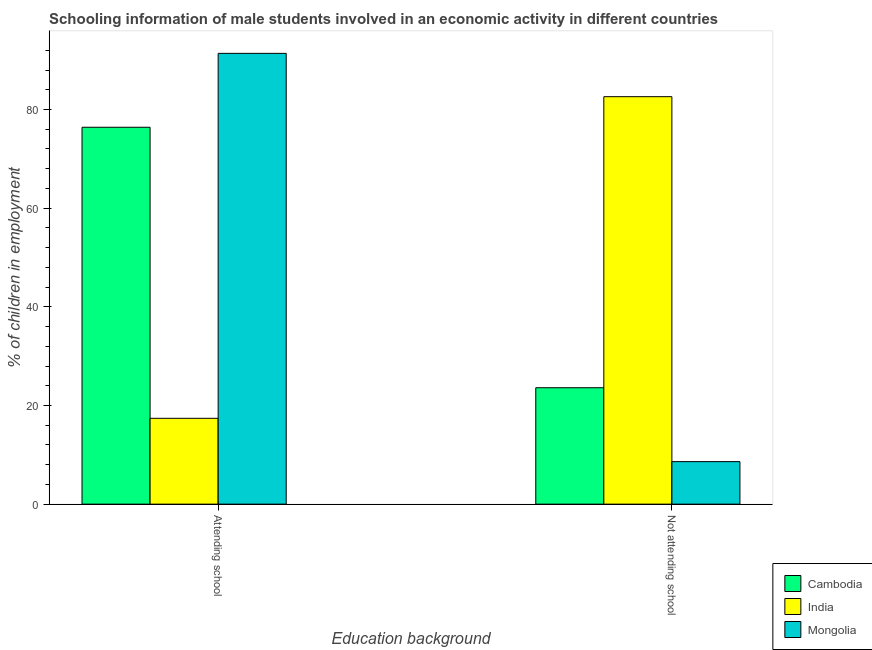Are the number of bars per tick equal to the number of legend labels?
Give a very brief answer. Yes. Are the number of bars on each tick of the X-axis equal?
Keep it short and to the point. Yes. How many bars are there on the 1st tick from the left?
Offer a very short reply. 3. How many bars are there on the 2nd tick from the right?
Give a very brief answer. 3. What is the label of the 1st group of bars from the left?
Keep it short and to the point. Attending school. What is the percentage of employed males who are attending school in Cambodia?
Your response must be concise. 76.4. Across all countries, what is the maximum percentage of employed males who are attending school?
Your answer should be very brief. 91.38. In which country was the percentage of employed males who are attending school maximum?
Keep it short and to the point. Mongolia. What is the total percentage of employed males who are attending school in the graph?
Offer a terse response. 185.18. What is the difference between the percentage of employed males who are attending school in Mongolia and that in India?
Ensure brevity in your answer.  73.98. What is the difference between the percentage of employed males who are attending school in Mongolia and the percentage of employed males who are not attending school in India?
Provide a short and direct response. 8.78. What is the average percentage of employed males who are attending school per country?
Make the answer very short. 61.73. What is the difference between the percentage of employed males who are not attending school and percentage of employed males who are attending school in Cambodia?
Offer a very short reply. -52.8. In how many countries, is the percentage of employed males who are not attending school greater than 44 %?
Make the answer very short. 1. What is the ratio of the percentage of employed males who are attending school in India to that in Cambodia?
Keep it short and to the point. 0.23. What does the 1st bar from the left in Not attending school represents?
Provide a succinct answer. Cambodia. What does the 3rd bar from the right in Attending school represents?
Ensure brevity in your answer.  Cambodia. How many countries are there in the graph?
Your response must be concise. 3. What is the difference between two consecutive major ticks on the Y-axis?
Keep it short and to the point. 20. Does the graph contain grids?
Provide a succinct answer. No. Where does the legend appear in the graph?
Offer a very short reply. Bottom right. What is the title of the graph?
Offer a very short reply. Schooling information of male students involved in an economic activity in different countries. What is the label or title of the X-axis?
Provide a short and direct response. Education background. What is the label or title of the Y-axis?
Offer a very short reply. % of children in employment. What is the % of children in employment in Cambodia in Attending school?
Keep it short and to the point. 76.4. What is the % of children in employment of Mongolia in Attending school?
Give a very brief answer. 91.38. What is the % of children in employment in Cambodia in Not attending school?
Provide a succinct answer. 23.6. What is the % of children in employment in India in Not attending school?
Offer a terse response. 82.6. What is the % of children in employment of Mongolia in Not attending school?
Your answer should be compact. 8.62. Across all Education background, what is the maximum % of children in employment of Cambodia?
Offer a very short reply. 76.4. Across all Education background, what is the maximum % of children in employment of India?
Keep it short and to the point. 82.6. Across all Education background, what is the maximum % of children in employment in Mongolia?
Give a very brief answer. 91.38. Across all Education background, what is the minimum % of children in employment of Cambodia?
Offer a very short reply. 23.6. Across all Education background, what is the minimum % of children in employment in India?
Provide a succinct answer. 17.4. Across all Education background, what is the minimum % of children in employment of Mongolia?
Make the answer very short. 8.62. What is the total % of children in employment of Cambodia in the graph?
Your answer should be compact. 100. What is the total % of children in employment of Mongolia in the graph?
Offer a very short reply. 100. What is the difference between the % of children in employment of Cambodia in Attending school and that in Not attending school?
Your answer should be very brief. 52.8. What is the difference between the % of children in employment of India in Attending school and that in Not attending school?
Your answer should be very brief. -65.2. What is the difference between the % of children in employment in Mongolia in Attending school and that in Not attending school?
Your answer should be very brief. 82.76. What is the difference between the % of children in employment of Cambodia in Attending school and the % of children in employment of Mongolia in Not attending school?
Your response must be concise. 67.78. What is the difference between the % of children in employment in India in Attending school and the % of children in employment in Mongolia in Not attending school?
Your answer should be compact. 8.78. What is the average % of children in employment in Cambodia per Education background?
Keep it short and to the point. 50. What is the difference between the % of children in employment of Cambodia and % of children in employment of India in Attending school?
Your answer should be compact. 59. What is the difference between the % of children in employment of Cambodia and % of children in employment of Mongolia in Attending school?
Ensure brevity in your answer.  -14.98. What is the difference between the % of children in employment of India and % of children in employment of Mongolia in Attending school?
Ensure brevity in your answer.  -73.98. What is the difference between the % of children in employment of Cambodia and % of children in employment of India in Not attending school?
Give a very brief answer. -59. What is the difference between the % of children in employment of Cambodia and % of children in employment of Mongolia in Not attending school?
Give a very brief answer. 14.98. What is the difference between the % of children in employment in India and % of children in employment in Mongolia in Not attending school?
Ensure brevity in your answer.  73.98. What is the ratio of the % of children in employment in Cambodia in Attending school to that in Not attending school?
Your response must be concise. 3.24. What is the ratio of the % of children in employment of India in Attending school to that in Not attending school?
Ensure brevity in your answer.  0.21. What is the ratio of the % of children in employment of Mongolia in Attending school to that in Not attending school?
Ensure brevity in your answer.  10.6. What is the difference between the highest and the second highest % of children in employment of Cambodia?
Provide a succinct answer. 52.8. What is the difference between the highest and the second highest % of children in employment of India?
Keep it short and to the point. 65.2. What is the difference between the highest and the second highest % of children in employment of Mongolia?
Offer a terse response. 82.76. What is the difference between the highest and the lowest % of children in employment in Cambodia?
Give a very brief answer. 52.8. What is the difference between the highest and the lowest % of children in employment in India?
Make the answer very short. 65.2. What is the difference between the highest and the lowest % of children in employment in Mongolia?
Offer a terse response. 82.76. 